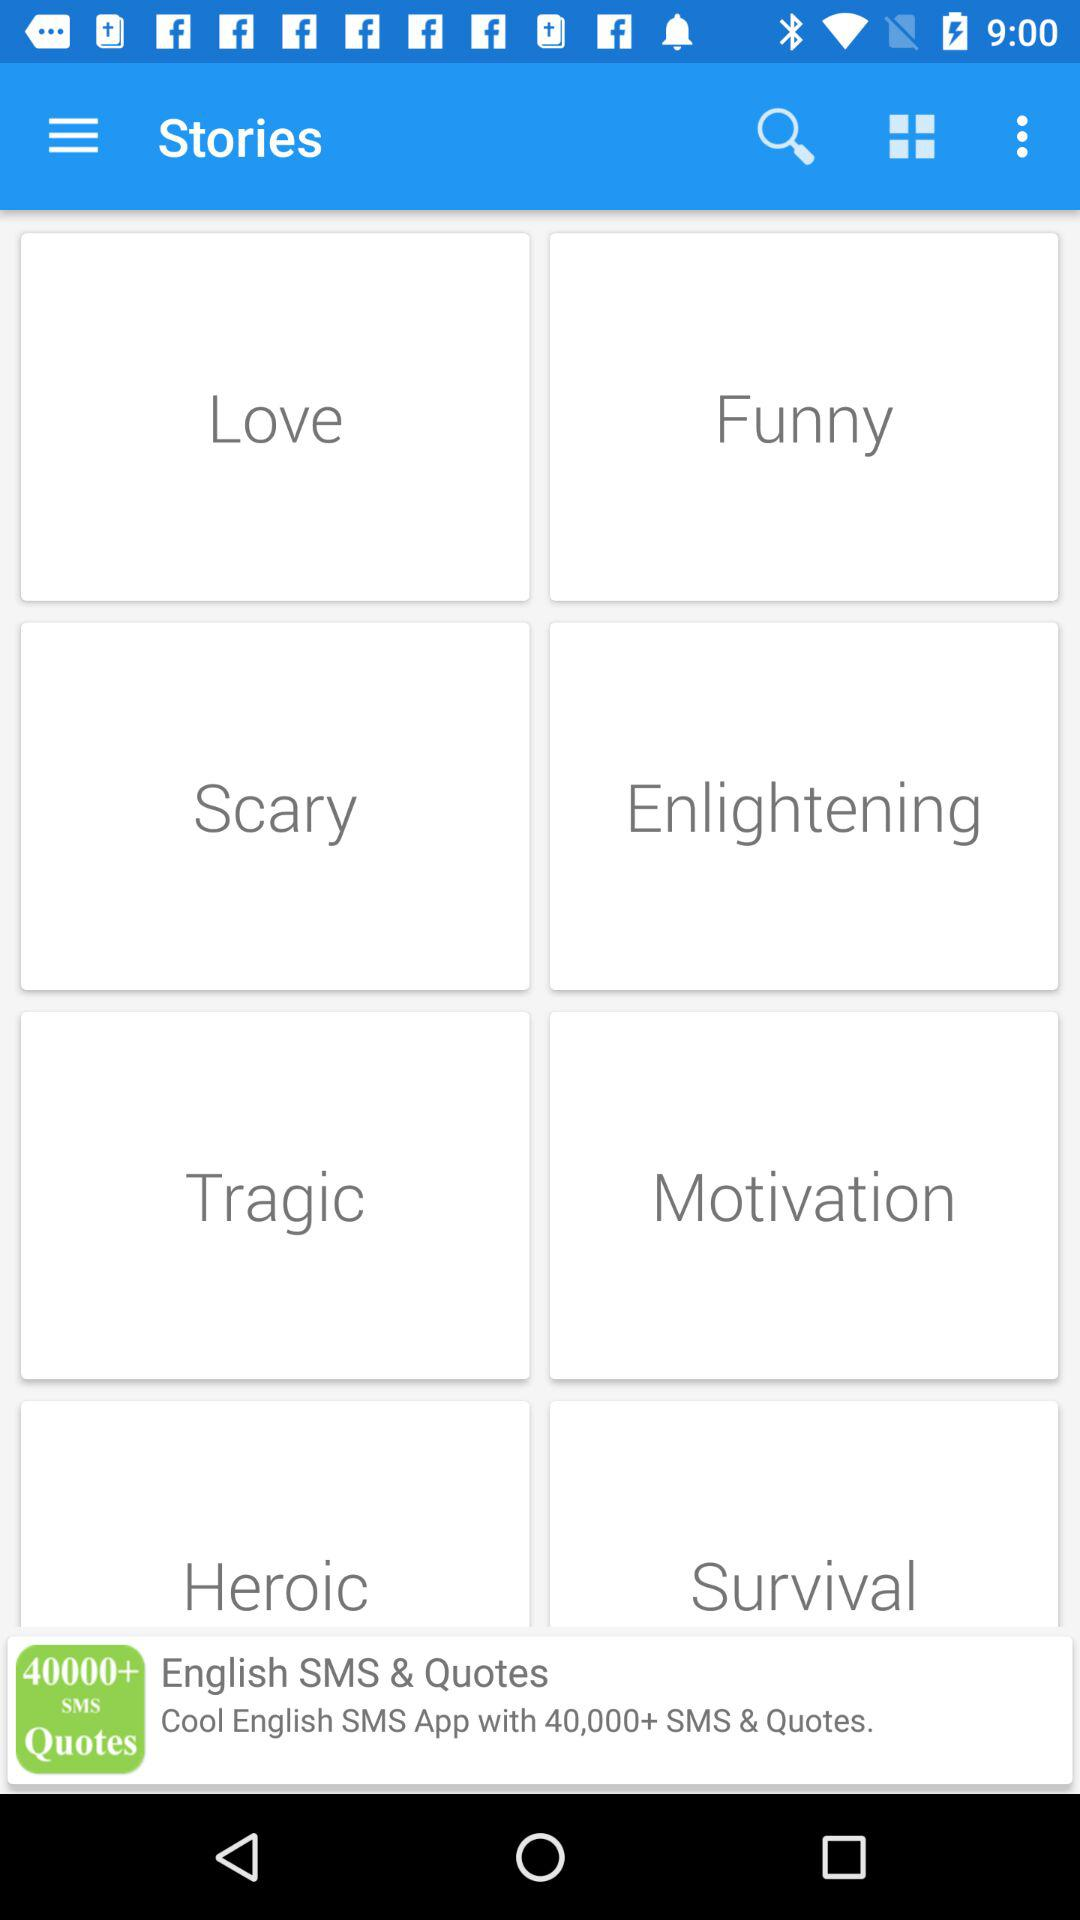Which types of stories can I read? You can read "Love", "Funny", "Scary", "Enlightening", "Tragic", "Motivation", "Heroic" and "Survival" stories. 